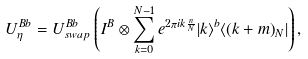<formula> <loc_0><loc_0><loc_500><loc_500>U _ { \eta } ^ { B b } = U ^ { B b } _ { s w a p } \left ( I ^ { B } \otimes \sum _ { k = 0 } ^ { N - 1 } e ^ { 2 \pi i k \frac { n } { N } } | k \rangle ^ { b } \langle ( k + m ) _ { N } | \right ) ,</formula> 